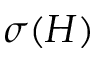<formula> <loc_0><loc_0><loc_500><loc_500>\sigma ( H )</formula> 